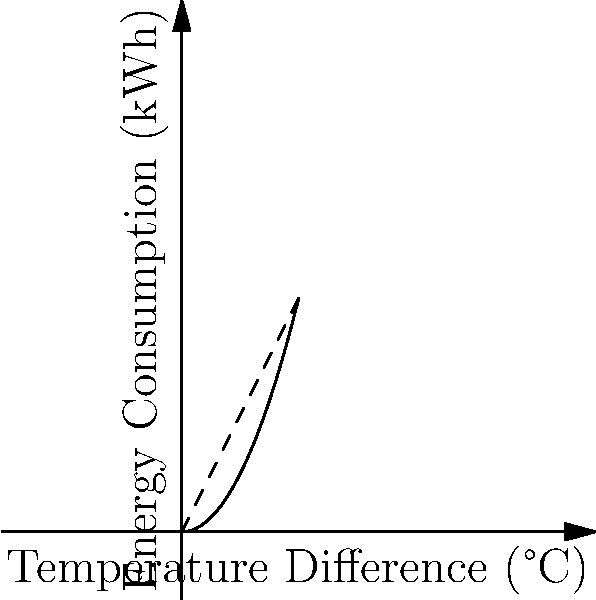As an Australian football fan familiar with large indoor arenas, you're consulting on the HVAC system for a new stadium. The graph shows energy consumption vs. temperature difference for two HVAC systems. What key factor contributes to the efficiency of the dashed line system compared to the solid line system? To answer this question, let's analyze the graph step-by-step:

1. The x-axis represents the temperature difference between the indoor and outdoor environments, while the y-axis shows energy consumption.

2. There are two curves: a solid line (inefficient system) and a dashed line (efficient system).

3. The solid line (inefficient system) is a quadratic function, approximately $f(x) = 0.5x^2$. This means energy consumption increases exponentially with temperature difference.

4. The dashed line (efficient system) is a linear function, approximately $g(x) = 2x$. This indicates a linear relationship between energy consumption and temperature difference.

5. At the operating point (2,2), both systems consume the same energy for a 2°C temperature difference.

6. As the temperature difference increases beyond 2°C, the inefficient system's energy consumption grows much faster than the efficient system's.

The key factor contributing to the efficiency of the dashed line system is its linear relationship between energy consumption and temperature difference. This suggests better temperature control and energy management, likely due to:

a) Variable speed compressors and fans that adjust output based on demand.
b) Improved insulation and air distribution systems that maintain consistent temperatures.
c) Advanced control systems that optimize performance across varying conditions.

These features allow the efficient system to maintain a constant rate of energy increase as temperature differences grow, unlike the inefficient system which requires exponentially more energy for larger temperature differences.
Answer: Linear energy-temperature relationship due to variable speed components and advanced controls 